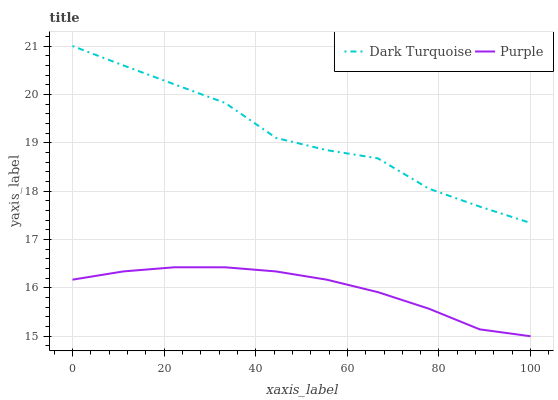Does Purple have the minimum area under the curve?
Answer yes or no. Yes. Does Dark Turquoise have the maximum area under the curve?
Answer yes or no. Yes. Does Dark Turquoise have the minimum area under the curve?
Answer yes or no. No. Is Purple the smoothest?
Answer yes or no. Yes. Is Dark Turquoise the roughest?
Answer yes or no. Yes. Is Dark Turquoise the smoothest?
Answer yes or no. No. Does Dark Turquoise have the lowest value?
Answer yes or no. No. Does Dark Turquoise have the highest value?
Answer yes or no. Yes. Is Purple less than Dark Turquoise?
Answer yes or no. Yes. Is Dark Turquoise greater than Purple?
Answer yes or no. Yes. Does Purple intersect Dark Turquoise?
Answer yes or no. No. 